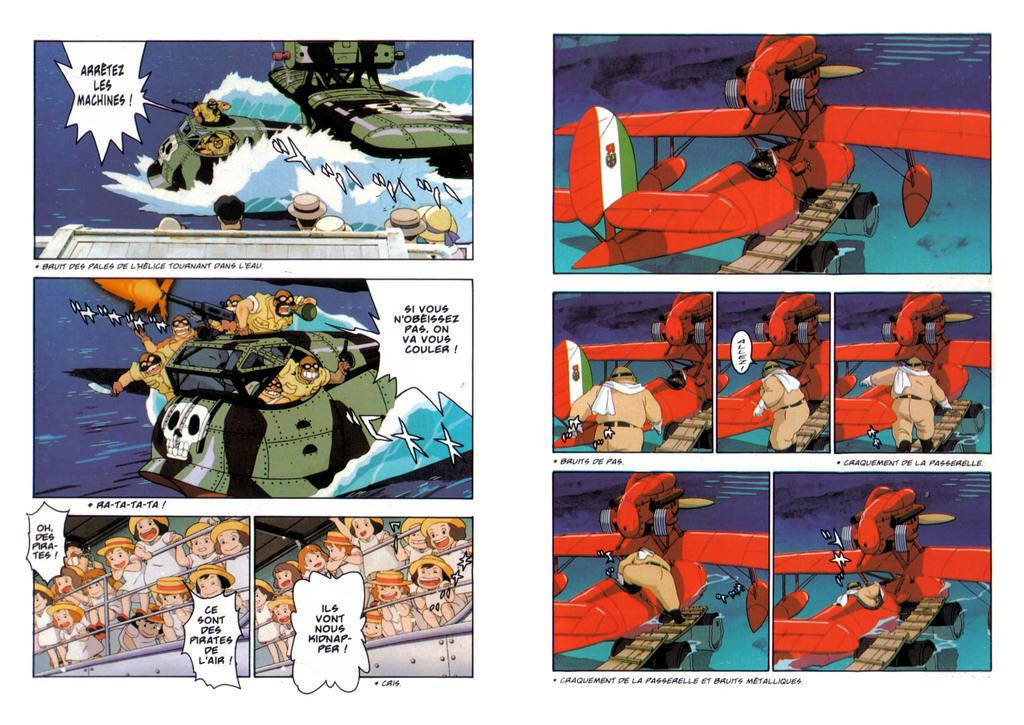What type of images can be seen in the picture? There are cartoon images in the picture. What else can be found in the picture besides the cartoon images? There is some information present in the picture. What type of clouds can be seen in the picture? There are no clouds present in the picture; it features cartoon images and information. 